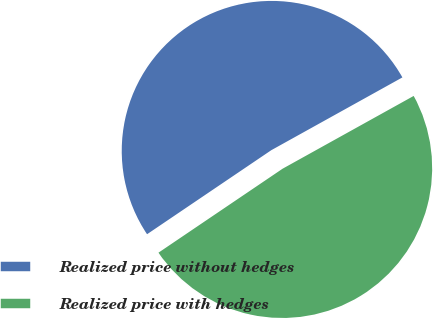Convert chart. <chart><loc_0><loc_0><loc_500><loc_500><pie_chart><fcel>Realized price without hedges<fcel>Realized price with hedges<nl><fcel>51.4%<fcel>48.6%<nl></chart> 